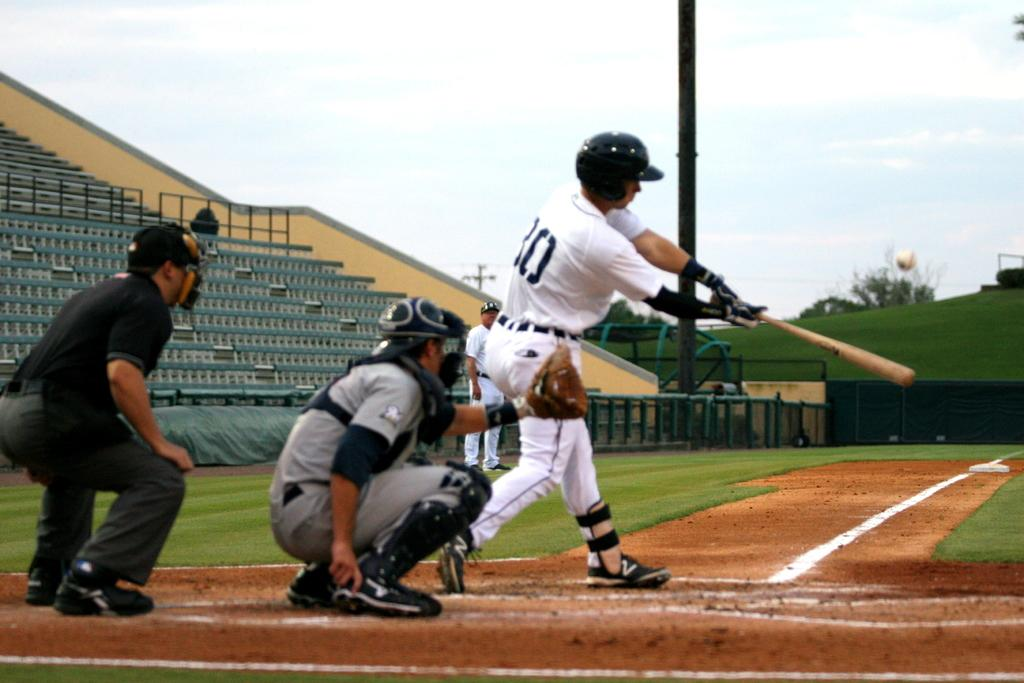<image>
Share a concise interpretation of the image provided. Player number 30 is at bat and taking a swing at the baseball. 